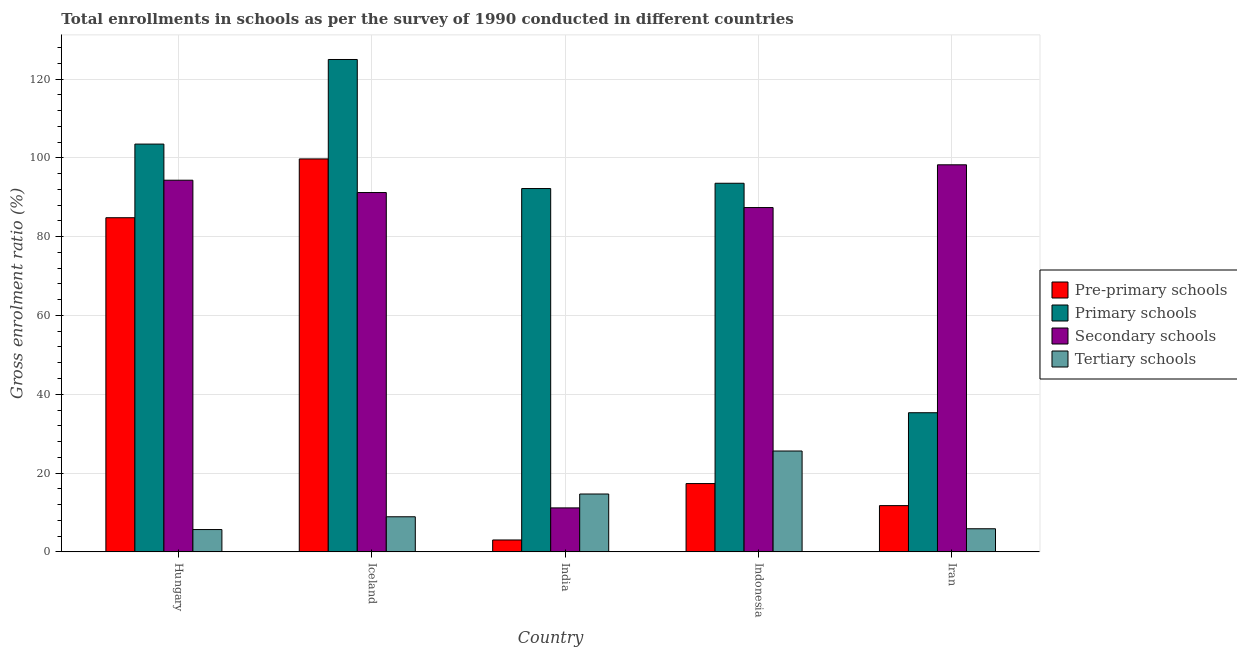How many bars are there on the 1st tick from the left?
Your answer should be compact. 4. What is the label of the 5th group of bars from the left?
Your response must be concise. Iran. In how many cases, is the number of bars for a given country not equal to the number of legend labels?
Your answer should be compact. 0. What is the gross enrolment ratio in pre-primary schools in Iran?
Provide a succinct answer. 11.74. Across all countries, what is the maximum gross enrolment ratio in tertiary schools?
Provide a short and direct response. 25.6. Across all countries, what is the minimum gross enrolment ratio in tertiary schools?
Offer a very short reply. 5.66. In which country was the gross enrolment ratio in primary schools maximum?
Your answer should be very brief. Iceland. In which country was the gross enrolment ratio in secondary schools minimum?
Your answer should be very brief. India. What is the total gross enrolment ratio in secondary schools in the graph?
Your answer should be compact. 382.27. What is the difference between the gross enrolment ratio in secondary schools in India and that in Iran?
Offer a very short reply. -87.06. What is the difference between the gross enrolment ratio in pre-primary schools in Indonesia and the gross enrolment ratio in tertiary schools in Iceland?
Give a very brief answer. 8.42. What is the average gross enrolment ratio in tertiary schools per country?
Your answer should be very brief. 12.14. What is the difference between the gross enrolment ratio in secondary schools and gross enrolment ratio in primary schools in Hungary?
Provide a short and direct response. -9.16. In how many countries, is the gross enrolment ratio in primary schools greater than 72 %?
Make the answer very short. 4. What is the ratio of the gross enrolment ratio in pre-primary schools in India to that in Indonesia?
Provide a succinct answer. 0.17. Is the difference between the gross enrolment ratio in tertiary schools in Iceland and Iran greater than the difference between the gross enrolment ratio in primary schools in Iceland and Iran?
Your response must be concise. No. What is the difference between the highest and the second highest gross enrolment ratio in secondary schools?
Make the answer very short. 3.91. What is the difference between the highest and the lowest gross enrolment ratio in secondary schools?
Offer a very short reply. 87.06. In how many countries, is the gross enrolment ratio in secondary schools greater than the average gross enrolment ratio in secondary schools taken over all countries?
Ensure brevity in your answer.  4. What does the 2nd bar from the left in Indonesia represents?
Provide a succinct answer. Primary schools. What does the 2nd bar from the right in Indonesia represents?
Your answer should be very brief. Secondary schools. Is it the case that in every country, the sum of the gross enrolment ratio in pre-primary schools and gross enrolment ratio in primary schools is greater than the gross enrolment ratio in secondary schools?
Your answer should be compact. No. Are all the bars in the graph horizontal?
Ensure brevity in your answer.  No. What is the difference between two consecutive major ticks on the Y-axis?
Offer a terse response. 20. Are the values on the major ticks of Y-axis written in scientific E-notation?
Your answer should be compact. No. Does the graph contain any zero values?
Provide a short and direct response. No. Does the graph contain grids?
Keep it short and to the point. Yes. How are the legend labels stacked?
Provide a short and direct response. Vertical. What is the title of the graph?
Give a very brief answer. Total enrollments in schools as per the survey of 1990 conducted in different countries. Does "Sweden" appear as one of the legend labels in the graph?
Provide a succinct answer. No. What is the label or title of the Y-axis?
Ensure brevity in your answer.  Gross enrolment ratio (%). What is the Gross enrolment ratio (%) of Pre-primary schools in Hungary?
Offer a very short reply. 84.8. What is the Gross enrolment ratio (%) in Primary schools in Hungary?
Your answer should be compact. 103.48. What is the Gross enrolment ratio (%) of Secondary schools in Hungary?
Give a very brief answer. 94.32. What is the Gross enrolment ratio (%) of Tertiary schools in Hungary?
Your answer should be very brief. 5.66. What is the Gross enrolment ratio (%) in Pre-primary schools in Iceland?
Provide a succinct answer. 99.72. What is the Gross enrolment ratio (%) of Primary schools in Iceland?
Ensure brevity in your answer.  124.95. What is the Gross enrolment ratio (%) of Secondary schools in Iceland?
Your answer should be very brief. 91.19. What is the Gross enrolment ratio (%) in Tertiary schools in Iceland?
Your response must be concise. 8.91. What is the Gross enrolment ratio (%) in Pre-primary schools in India?
Provide a short and direct response. 3.02. What is the Gross enrolment ratio (%) in Primary schools in India?
Provide a short and direct response. 92.2. What is the Gross enrolment ratio (%) in Secondary schools in India?
Your response must be concise. 11.16. What is the Gross enrolment ratio (%) in Tertiary schools in India?
Provide a short and direct response. 14.69. What is the Gross enrolment ratio (%) of Pre-primary schools in Indonesia?
Make the answer very short. 17.33. What is the Gross enrolment ratio (%) of Primary schools in Indonesia?
Make the answer very short. 93.54. What is the Gross enrolment ratio (%) in Secondary schools in Indonesia?
Keep it short and to the point. 87.38. What is the Gross enrolment ratio (%) in Tertiary schools in Indonesia?
Give a very brief answer. 25.6. What is the Gross enrolment ratio (%) of Pre-primary schools in Iran?
Give a very brief answer. 11.74. What is the Gross enrolment ratio (%) in Primary schools in Iran?
Your answer should be very brief. 35.31. What is the Gross enrolment ratio (%) of Secondary schools in Iran?
Make the answer very short. 98.23. What is the Gross enrolment ratio (%) of Tertiary schools in Iran?
Provide a succinct answer. 5.87. Across all countries, what is the maximum Gross enrolment ratio (%) of Pre-primary schools?
Your response must be concise. 99.72. Across all countries, what is the maximum Gross enrolment ratio (%) in Primary schools?
Provide a short and direct response. 124.95. Across all countries, what is the maximum Gross enrolment ratio (%) of Secondary schools?
Offer a terse response. 98.23. Across all countries, what is the maximum Gross enrolment ratio (%) in Tertiary schools?
Provide a succinct answer. 25.6. Across all countries, what is the minimum Gross enrolment ratio (%) of Pre-primary schools?
Make the answer very short. 3.02. Across all countries, what is the minimum Gross enrolment ratio (%) in Primary schools?
Provide a short and direct response. 35.31. Across all countries, what is the minimum Gross enrolment ratio (%) of Secondary schools?
Your answer should be very brief. 11.16. Across all countries, what is the minimum Gross enrolment ratio (%) in Tertiary schools?
Offer a very short reply. 5.66. What is the total Gross enrolment ratio (%) in Pre-primary schools in the graph?
Your answer should be very brief. 216.6. What is the total Gross enrolment ratio (%) of Primary schools in the graph?
Your response must be concise. 449.49. What is the total Gross enrolment ratio (%) of Secondary schools in the graph?
Offer a very short reply. 382.27. What is the total Gross enrolment ratio (%) of Tertiary schools in the graph?
Keep it short and to the point. 60.72. What is the difference between the Gross enrolment ratio (%) in Pre-primary schools in Hungary and that in Iceland?
Provide a short and direct response. -14.92. What is the difference between the Gross enrolment ratio (%) in Primary schools in Hungary and that in Iceland?
Give a very brief answer. -21.47. What is the difference between the Gross enrolment ratio (%) of Secondary schools in Hungary and that in Iceland?
Offer a very short reply. 3.13. What is the difference between the Gross enrolment ratio (%) in Tertiary schools in Hungary and that in Iceland?
Your answer should be compact. -3.24. What is the difference between the Gross enrolment ratio (%) in Pre-primary schools in Hungary and that in India?
Offer a terse response. 81.78. What is the difference between the Gross enrolment ratio (%) in Primary schools in Hungary and that in India?
Your answer should be compact. 11.28. What is the difference between the Gross enrolment ratio (%) of Secondary schools in Hungary and that in India?
Offer a very short reply. 83.16. What is the difference between the Gross enrolment ratio (%) of Tertiary schools in Hungary and that in India?
Keep it short and to the point. -9.02. What is the difference between the Gross enrolment ratio (%) in Pre-primary schools in Hungary and that in Indonesia?
Keep it short and to the point. 67.46. What is the difference between the Gross enrolment ratio (%) of Primary schools in Hungary and that in Indonesia?
Make the answer very short. 9.94. What is the difference between the Gross enrolment ratio (%) of Secondary schools in Hungary and that in Indonesia?
Keep it short and to the point. 6.94. What is the difference between the Gross enrolment ratio (%) in Tertiary schools in Hungary and that in Indonesia?
Provide a short and direct response. -19.93. What is the difference between the Gross enrolment ratio (%) of Pre-primary schools in Hungary and that in Iran?
Offer a terse response. 73.06. What is the difference between the Gross enrolment ratio (%) in Primary schools in Hungary and that in Iran?
Your answer should be compact. 68.17. What is the difference between the Gross enrolment ratio (%) in Secondary schools in Hungary and that in Iran?
Offer a very short reply. -3.91. What is the difference between the Gross enrolment ratio (%) of Tertiary schools in Hungary and that in Iran?
Keep it short and to the point. -0.2. What is the difference between the Gross enrolment ratio (%) of Pre-primary schools in Iceland and that in India?
Give a very brief answer. 96.7. What is the difference between the Gross enrolment ratio (%) of Primary schools in Iceland and that in India?
Ensure brevity in your answer.  32.75. What is the difference between the Gross enrolment ratio (%) of Secondary schools in Iceland and that in India?
Make the answer very short. 80.03. What is the difference between the Gross enrolment ratio (%) in Tertiary schools in Iceland and that in India?
Offer a very short reply. -5.78. What is the difference between the Gross enrolment ratio (%) in Pre-primary schools in Iceland and that in Indonesia?
Keep it short and to the point. 82.38. What is the difference between the Gross enrolment ratio (%) of Primary schools in Iceland and that in Indonesia?
Provide a succinct answer. 31.41. What is the difference between the Gross enrolment ratio (%) in Secondary schools in Iceland and that in Indonesia?
Your answer should be very brief. 3.81. What is the difference between the Gross enrolment ratio (%) in Tertiary schools in Iceland and that in Indonesia?
Offer a very short reply. -16.69. What is the difference between the Gross enrolment ratio (%) of Pre-primary schools in Iceland and that in Iran?
Ensure brevity in your answer.  87.98. What is the difference between the Gross enrolment ratio (%) of Primary schools in Iceland and that in Iran?
Your answer should be compact. 89.64. What is the difference between the Gross enrolment ratio (%) of Secondary schools in Iceland and that in Iran?
Your answer should be compact. -7.04. What is the difference between the Gross enrolment ratio (%) in Tertiary schools in Iceland and that in Iran?
Offer a terse response. 3.04. What is the difference between the Gross enrolment ratio (%) in Pre-primary schools in India and that in Indonesia?
Your answer should be compact. -14.32. What is the difference between the Gross enrolment ratio (%) of Primary schools in India and that in Indonesia?
Provide a succinct answer. -1.34. What is the difference between the Gross enrolment ratio (%) of Secondary schools in India and that in Indonesia?
Your answer should be very brief. -76.22. What is the difference between the Gross enrolment ratio (%) of Tertiary schools in India and that in Indonesia?
Provide a succinct answer. -10.91. What is the difference between the Gross enrolment ratio (%) of Pre-primary schools in India and that in Iran?
Offer a very short reply. -8.72. What is the difference between the Gross enrolment ratio (%) of Primary schools in India and that in Iran?
Your response must be concise. 56.89. What is the difference between the Gross enrolment ratio (%) in Secondary schools in India and that in Iran?
Provide a succinct answer. -87.06. What is the difference between the Gross enrolment ratio (%) in Tertiary schools in India and that in Iran?
Offer a very short reply. 8.82. What is the difference between the Gross enrolment ratio (%) in Pre-primary schools in Indonesia and that in Iran?
Provide a short and direct response. 5.6. What is the difference between the Gross enrolment ratio (%) of Primary schools in Indonesia and that in Iran?
Provide a succinct answer. 58.23. What is the difference between the Gross enrolment ratio (%) of Secondary schools in Indonesia and that in Iran?
Ensure brevity in your answer.  -10.85. What is the difference between the Gross enrolment ratio (%) in Tertiary schools in Indonesia and that in Iran?
Your response must be concise. 19.73. What is the difference between the Gross enrolment ratio (%) in Pre-primary schools in Hungary and the Gross enrolment ratio (%) in Primary schools in Iceland?
Your answer should be compact. -40.15. What is the difference between the Gross enrolment ratio (%) of Pre-primary schools in Hungary and the Gross enrolment ratio (%) of Secondary schools in Iceland?
Make the answer very short. -6.39. What is the difference between the Gross enrolment ratio (%) in Pre-primary schools in Hungary and the Gross enrolment ratio (%) in Tertiary schools in Iceland?
Make the answer very short. 75.89. What is the difference between the Gross enrolment ratio (%) of Primary schools in Hungary and the Gross enrolment ratio (%) of Secondary schools in Iceland?
Make the answer very short. 12.29. What is the difference between the Gross enrolment ratio (%) of Primary schools in Hungary and the Gross enrolment ratio (%) of Tertiary schools in Iceland?
Offer a terse response. 94.57. What is the difference between the Gross enrolment ratio (%) of Secondary schools in Hungary and the Gross enrolment ratio (%) of Tertiary schools in Iceland?
Your answer should be compact. 85.41. What is the difference between the Gross enrolment ratio (%) in Pre-primary schools in Hungary and the Gross enrolment ratio (%) in Primary schools in India?
Offer a very short reply. -7.4. What is the difference between the Gross enrolment ratio (%) of Pre-primary schools in Hungary and the Gross enrolment ratio (%) of Secondary schools in India?
Provide a short and direct response. 73.64. What is the difference between the Gross enrolment ratio (%) of Pre-primary schools in Hungary and the Gross enrolment ratio (%) of Tertiary schools in India?
Make the answer very short. 70.11. What is the difference between the Gross enrolment ratio (%) of Primary schools in Hungary and the Gross enrolment ratio (%) of Secondary schools in India?
Your response must be concise. 92.32. What is the difference between the Gross enrolment ratio (%) in Primary schools in Hungary and the Gross enrolment ratio (%) in Tertiary schools in India?
Your answer should be very brief. 88.8. What is the difference between the Gross enrolment ratio (%) of Secondary schools in Hungary and the Gross enrolment ratio (%) of Tertiary schools in India?
Make the answer very short. 79.63. What is the difference between the Gross enrolment ratio (%) in Pre-primary schools in Hungary and the Gross enrolment ratio (%) in Primary schools in Indonesia?
Provide a short and direct response. -8.74. What is the difference between the Gross enrolment ratio (%) of Pre-primary schools in Hungary and the Gross enrolment ratio (%) of Secondary schools in Indonesia?
Make the answer very short. -2.58. What is the difference between the Gross enrolment ratio (%) of Pre-primary schools in Hungary and the Gross enrolment ratio (%) of Tertiary schools in Indonesia?
Your response must be concise. 59.2. What is the difference between the Gross enrolment ratio (%) in Primary schools in Hungary and the Gross enrolment ratio (%) in Secondary schools in Indonesia?
Make the answer very short. 16.11. What is the difference between the Gross enrolment ratio (%) in Primary schools in Hungary and the Gross enrolment ratio (%) in Tertiary schools in Indonesia?
Your answer should be very brief. 77.89. What is the difference between the Gross enrolment ratio (%) of Secondary schools in Hungary and the Gross enrolment ratio (%) of Tertiary schools in Indonesia?
Make the answer very short. 68.72. What is the difference between the Gross enrolment ratio (%) of Pre-primary schools in Hungary and the Gross enrolment ratio (%) of Primary schools in Iran?
Keep it short and to the point. 49.49. What is the difference between the Gross enrolment ratio (%) in Pre-primary schools in Hungary and the Gross enrolment ratio (%) in Secondary schools in Iran?
Ensure brevity in your answer.  -13.43. What is the difference between the Gross enrolment ratio (%) in Pre-primary schools in Hungary and the Gross enrolment ratio (%) in Tertiary schools in Iran?
Offer a terse response. 78.93. What is the difference between the Gross enrolment ratio (%) in Primary schools in Hungary and the Gross enrolment ratio (%) in Secondary schools in Iran?
Offer a terse response. 5.26. What is the difference between the Gross enrolment ratio (%) of Primary schools in Hungary and the Gross enrolment ratio (%) of Tertiary schools in Iran?
Give a very brief answer. 97.62. What is the difference between the Gross enrolment ratio (%) of Secondary schools in Hungary and the Gross enrolment ratio (%) of Tertiary schools in Iran?
Your response must be concise. 88.45. What is the difference between the Gross enrolment ratio (%) of Pre-primary schools in Iceland and the Gross enrolment ratio (%) of Primary schools in India?
Ensure brevity in your answer.  7.52. What is the difference between the Gross enrolment ratio (%) of Pre-primary schools in Iceland and the Gross enrolment ratio (%) of Secondary schools in India?
Provide a short and direct response. 88.56. What is the difference between the Gross enrolment ratio (%) in Pre-primary schools in Iceland and the Gross enrolment ratio (%) in Tertiary schools in India?
Make the answer very short. 85.03. What is the difference between the Gross enrolment ratio (%) in Primary schools in Iceland and the Gross enrolment ratio (%) in Secondary schools in India?
Offer a very short reply. 113.79. What is the difference between the Gross enrolment ratio (%) in Primary schools in Iceland and the Gross enrolment ratio (%) in Tertiary schools in India?
Your answer should be very brief. 110.26. What is the difference between the Gross enrolment ratio (%) in Secondary schools in Iceland and the Gross enrolment ratio (%) in Tertiary schools in India?
Your answer should be very brief. 76.5. What is the difference between the Gross enrolment ratio (%) in Pre-primary schools in Iceland and the Gross enrolment ratio (%) in Primary schools in Indonesia?
Keep it short and to the point. 6.17. What is the difference between the Gross enrolment ratio (%) of Pre-primary schools in Iceland and the Gross enrolment ratio (%) of Secondary schools in Indonesia?
Offer a very short reply. 12.34. What is the difference between the Gross enrolment ratio (%) in Pre-primary schools in Iceland and the Gross enrolment ratio (%) in Tertiary schools in Indonesia?
Offer a terse response. 74.12. What is the difference between the Gross enrolment ratio (%) of Primary schools in Iceland and the Gross enrolment ratio (%) of Secondary schools in Indonesia?
Provide a succinct answer. 37.57. What is the difference between the Gross enrolment ratio (%) of Primary schools in Iceland and the Gross enrolment ratio (%) of Tertiary schools in Indonesia?
Make the answer very short. 99.35. What is the difference between the Gross enrolment ratio (%) in Secondary schools in Iceland and the Gross enrolment ratio (%) in Tertiary schools in Indonesia?
Your answer should be compact. 65.59. What is the difference between the Gross enrolment ratio (%) in Pre-primary schools in Iceland and the Gross enrolment ratio (%) in Primary schools in Iran?
Your answer should be very brief. 64.41. What is the difference between the Gross enrolment ratio (%) in Pre-primary schools in Iceland and the Gross enrolment ratio (%) in Secondary schools in Iran?
Offer a very short reply. 1.49. What is the difference between the Gross enrolment ratio (%) in Pre-primary schools in Iceland and the Gross enrolment ratio (%) in Tertiary schools in Iran?
Offer a very short reply. 93.85. What is the difference between the Gross enrolment ratio (%) of Primary schools in Iceland and the Gross enrolment ratio (%) of Secondary schools in Iran?
Your response must be concise. 26.73. What is the difference between the Gross enrolment ratio (%) of Primary schools in Iceland and the Gross enrolment ratio (%) of Tertiary schools in Iran?
Your answer should be very brief. 119.08. What is the difference between the Gross enrolment ratio (%) in Secondary schools in Iceland and the Gross enrolment ratio (%) in Tertiary schools in Iran?
Your response must be concise. 85.32. What is the difference between the Gross enrolment ratio (%) in Pre-primary schools in India and the Gross enrolment ratio (%) in Primary schools in Indonesia?
Make the answer very short. -90.52. What is the difference between the Gross enrolment ratio (%) of Pre-primary schools in India and the Gross enrolment ratio (%) of Secondary schools in Indonesia?
Offer a very short reply. -84.36. What is the difference between the Gross enrolment ratio (%) in Pre-primary schools in India and the Gross enrolment ratio (%) in Tertiary schools in Indonesia?
Your answer should be very brief. -22.58. What is the difference between the Gross enrolment ratio (%) of Primary schools in India and the Gross enrolment ratio (%) of Secondary schools in Indonesia?
Your response must be concise. 4.82. What is the difference between the Gross enrolment ratio (%) of Primary schools in India and the Gross enrolment ratio (%) of Tertiary schools in Indonesia?
Your answer should be compact. 66.6. What is the difference between the Gross enrolment ratio (%) of Secondary schools in India and the Gross enrolment ratio (%) of Tertiary schools in Indonesia?
Offer a terse response. -14.44. What is the difference between the Gross enrolment ratio (%) of Pre-primary schools in India and the Gross enrolment ratio (%) of Primary schools in Iran?
Your response must be concise. -32.29. What is the difference between the Gross enrolment ratio (%) of Pre-primary schools in India and the Gross enrolment ratio (%) of Secondary schools in Iran?
Your answer should be compact. -95.21. What is the difference between the Gross enrolment ratio (%) in Pre-primary schools in India and the Gross enrolment ratio (%) in Tertiary schools in Iran?
Provide a succinct answer. -2.85. What is the difference between the Gross enrolment ratio (%) of Primary schools in India and the Gross enrolment ratio (%) of Secondary schools in Iran?
Provide a short and direct response. -6.02. What is the difference between the Gross enrolment ratio (%) in Primary schools in India and the Gross enrolment ratio (%) in Tertiary schools in Iran?
Provide a short and direct response. 86.34. What is the difference between the Gross enrolment ratio (%) of Secondary schools in India and the Gross enrolment ratio (%) of Tertiary schools in Iran?
Offer a very short reply. 5.3. What is the difference between the Gross enrolment ratio (%) of Pre-primary schools in Indonesia and the Gross enrolment ratio (%) of Primary schools in Iran?
Offer a terse response. -17.98. What is the difference between the Gross enrolment ratio (%) of Pre-primary schools in Indonesia and the Gross enrolment ratio (%) of Secondary schools in Iran?
Your answer should be compact. -80.89. What is the difference between the Gross enrolment ratio (%) of Pre-primary schools in Indonesia and the Gross enrolment ratio (%) of Tertiary schools in Iran?
Offer a very short reply. 11.47. What is the difference between the Gross enrolment ratio (%) in Primary schools in Indonesia and the Gross enrolment ratio (%) in Secondary schools in Iran?
Offer a very short reply. -4.68. What is the difference between the Gross enrolment ratio (%) of Primary schools in Indonesia and the Gross enrolment ratio (%) of Tertiary schools in Iran?
Provide a short and direct response. 87.68. What is the difference between the Gross enrolment ratio (%) of Secondary schools in Indonesia and the Gross enrolment ratio (%) of Tertiary schools in Iran?
Provide a short and direct response. 81.51. What is the average Gross enrolment ratio (%) in Pre-primary schools per country?
Your answer should be very brief. 43.32. What is the average Gross enrolment ratio (%) of Primary schools per country?
Give a very brief answer. 89.9. What is the average Gross enrolment ratio (%) of Secondary schools per country?
Make the answer very short. 76.45. What is the average Gross enrolment ratio (%) in Tertiary schools per country?
Give a very brief answer. 12.14. What is the difference between the Gross enrolment ratio (%) of Pre-primary schools and Gross enrolment ratio (%) of Primary schools in Hungary?
Your answer should be compact. -18.68. What is the difference between the Gross enrolment ratio (%) of Pre-primary schools and Gross enrolment ratio (%) of Secondary schools in Hungary?
Keep it short and to the point. -9.52. What is the difference between the Gross enrolment ratio (%) in Pre-primary schools and Gross enrolment ratio (%) in Tertiary schools in Hungary?
Provide a short and direct response. 79.13. What is the difference between the Gross enrolment ratio (%) of Primary schools and Gross enrolment ratio (%) of Secondary schools in Hungary?
Your answer should be very brief. 9.16. What is the difference between the Gross enrolment ratio (%) in Primary schools and Gross enrolment ratio (%) in Tertiary schools in Hungary?
Ensure brevity in your answer.  97.82. What is the difference between the Gross enrolment ratio (%) in Secondary schools and Gross enrolment ratio (%) in Tertiary schools in Hungary?
Keep it short and to the point. 88.65. What is the difference between the Gross enrolment ratio (%) of Pre-primary schools and Gross enrolment ratio (%) of Primary schools in Iceland?
Ensure brevity in your answer.  -25.23. What is the difference between the Gross enrolment ratio (%) of Pre-primary schools and Gross enrolment ratio (%) of Secondary schools in Iceland?
Provide a short and direct response. 8.53. What is the difference between the Gross enrolment ratio (%) in Pre-primary schools and Gross enrolment ratio (%) in Tertiary schools in Iceland?
Provide a short and direct response. 90.81. What is the difference between the Gross enrolment ratio (%) of Primary schools and Gross enrolment ratio (%) of Secondary schools in Iceland?
Keep it short and to the point. 33.76. What is the difference between the Gross enrolment ratio (%) of Primary schools and Gross enrolment ratio (%) of Tertiary schools in Iceland?
Your answer should be very brief. 116.04. What is the difference between the Gross enrolment ratio (%) of Secondary schools and Gross enrolment ratio (%) of Tertiary schools in Iceland?
Provide a succinct answer. 82.28. What is the difference between the Gross enrolment ratio (%) of Pre-primary schools and Gross enrolment ratio (%) of Primary schools in India?
Ensure brevity in your answer.  -89.18. What is the difference between the Gross enrolment ratio (%) of Pre-primary schools and Gross enrolment ratio (%) of Secondary schools in India?
Provide a succinct answer. -8.14. What is the difference between the Gross enrolment ratio (%) of Pre-primary schools and Gross enrolment ratio (%) of Tertiary schools in India?
Make the answer very short. -11.67. What is the difference between the Gross enrolment ratio (%) in Primary schools and Gross enrolment ratio (%) in Secondary schools in India?
Provide a short and direct response. 81.04. What is the difference between the Gross enrolment ratio (%) in Primary schools and Gross enrolment ratio (%) in Tertiary schools in India?
Ensure brevity in your answer.  77.52. What is the difference between the Gross enrolment ratio (%) in Secondary schools and Gross enrolment ratio (%) in Tertiary schools in India?
Make the answer very short. -3.52. What is the difference between the Gross enrolment ratio (%) of Pre-primary schools and Gross enrolment ratio (%) of Primary schools in Indonesia?
Provide a succinct answer. -76.21. What is the difference between the Gross enrolment ratio (%) in Pre-primary schools and Gross enrolment ratio (%) in Secondary schools in Indonesia?
Provide a short and direct response. -70.04. What is the difference between the Gross enrolment ratio (%) of Pre-primary schools and Gross enrolment ratio (%) of Tertiary schools in Indonesia?
Your answer should be very brief. -8.26. What is the difference between the Gross enrolment ratio (%) of Primary schools and Gross enrolment ratio (%) of Secondary schools in Indonesia?
Ensure brevity in your answer.  6.17. What is the difference between the Gross enrolment ratio (%) of Primary schools and Gross enrolment ratio (%) of Tertiary schools in Indonesia?
Give a very brief answer. 67.95. What is the difference between the Gross enrolment ratio (%) in Secondary schools and Gross enrolment ratio (%) in Tertiary schools in Indonesia?
Offer a very short reply. 61.78. What is the difference between the Gross enrolment ratio (%) of Pre-primary schools and Gross enrolment ratio (%) of Primary schools in Iran?
Offer a very short reply. -23.57. What is the difference between the Gross enrolment ratio (%) in Pre-primary schools and Gross enrolment ratio (%) in Secondary schools in Iran?
Make the answer very short. -86.49. What is the difference between the Gross enrolment ratio (%) in Pre-primary schools and Gross enrolment ratio (%) in Tertiary schools in Iran?
Your answer should be very brief. 5.87. What is the difference between the Gross enrolment ratio (%) in Primary schools and Gross enrolment ratio (%) in Secondary schools in Iran?
Make the answer very short. -62.92. What is the difference between the Gross enrolment ratio (%) in Primary schools and Gross enrolment ratio (%) in Tertiary schools in Iran?
Make the answer very short. 29.44. What is the difference between the Gross enrolment ratio (%) in Secondary schools and Gross enrolment ratio (%) in Tertiary schools in Iran?
Your answer should be compact. 92.36. What is the ratio of the Gross enrolment ratio (%) in Pre-primary schools in Hungary to that in Iceland?
Provide a succinct answer. 0.85. What is the ratio of the Gross enrolment ratio (%) in Primary schools in Hungary to that in Iceland?
Offer a terse response. 0.83. What is the ratio of the Gross enrolment ratio (%) of Secondary schools in Hungary to that in Iceland?
Make the answer very short. 1.03. What is the ratio of the Gross enrolment ratio (%) in Tertiary schools in Hungary to that in Iceland?
Offer a very short reply. 0.64. What is the ratio of the Gross enrolment ratio (%) in Pre-primary schools in Hungary to that in India?
Give a very brief answer. 28.09. What is the ratio of the Gross enrolment ratio (%) of Primary schools in Hungary to that in India?
Your answer should be very brief. 1.12. What is the ratio of the Gross enrolment ratio (%) of Secondary schools in Hungary to that in India?
Your answer should be compact. 8.45. What is the ratio of the Gross enrolment ratio (%) of Tertiary schools in Hungary to that in India?
Offer a very short reply. 0.39. What is the ratio of the Gross enrolment ratio (%) in Pre-primary schools in Hungary to that in Indonesia?
Provide a short and direct response. 4.89. What is the ratio of the Gross enrolment ratio (%) in Primary schools in Hungary to that in Indonesia?
Give a very brief answer. 1.11. What is the ratio of the Gross enrolment ratio (%) of Secondary schools in Hungary to that in Indonesia?
Provide a short and direct response. 1.08. What is the ratio of the Gross enrolment ratio (%) in Tertiary schools in Hungary to that in Indonesia?
Ensure brevity in your answer.  0.22. What is the ratio of the Gross enrolment ratio (%) in Pre-primary schools in Hungary to that in Iran?
Make the answer very short. 7.22. What is the ratio of the Gross enrolment ratio (%) in Primary schools in Hungary to that in Iran?
Give a very brief answer. 2.93. What is the ratio of the Gross enrolment ratio (%) of Secondary schools in Hungary to that in Iran?
Keep it short and to the point. 0.96. What is the ratio of the Gross enrolment ratio (%) of Tertiary schools in Hungary to that in Iran?
Your answer should be compact. 0.97. What is the ratio of the Gross enrolment ratio (%) of Pre-primary schools in Iceland to that in India?
Ensure brevity in your answer.  33.04. What is the ratio of the Gross enrolment ratio (%) in Primary schools in Iceland to that in India?
Offer a very short reply. 1.36. What is the ratio of the Gross enrolment ratio (%) in Secondary schools in Iceland to that in India?
Provide a succinct answer. 8.17. What is the ratio of the Gross enrolment ratio (%) of Tertiary schools in Iceland to that in India?
Offer a terse response. 0.61. What is the ratio of the Gross enrolment ratio (%) in Pre-primary schools in Iceland to that in Indonesia?
Offer a terse response. 5.75. What is the ratio of the Gross enrolment ratio (%) of Primary schools in Iceland to that in Indonesia?
Offer a terse response. 1.34. What is the ratio of the Gross enrolment ratio (%) in Secondary schools in Iceland to that in Indonesia?
Give a very brief answer. 1.04. What is the ratio of the Gross enrolment ratio (%) in Tertiary schools in Iceland to that in Indonesia?
Provide a short and direct response. 0.35. What is the ratio of the Gross enrolment ratio (%) in Pre-primary schools in Iceland to that in Iran?
Your response must be concise. 8.5. What is the ratio of the Gross enrolment ratio (%) of Primary schools in Iceland to that in Iran?
Offer a terse response. 3.54. What is the ratio of the Gross enrolment ratio (%) in Secondary schools in Iceland to that in Iran?
Your answer should be compact. 0.93. What is the ratio of the Gross enrolment ratio (%) in Tertiary schools in Iceland to that in Iran?
Give a very brief answer. 1.52. What is the ratio of the Gross enrolment ratio (%) in Pre-primary schools in India to that in Indonesia?
Your answer should be very brief. 0.17. What is the ratio of the Gross enrolment ratio (%) in Primary schools in India to that in Indonesia?
Your answer should be very brief. 0.99. What is the ratio of the Gross enrolment ratio (%) in Secondary schools in India to that in Indonesia?
Offer a very short reply. 0.13. What is the ratio of the Gross enrolment ratio (%) of Tertiary schools in India to that in Indonesia?
Your response must be concise. 0.57. What is the ratio of the Gross enrolment ratio (%) of Pre-primary schools in India to that in Iran?
Provide a succinct answer. 0.26. What is the ratio of the Gross enrolment ratio (%) of Primary schools in India to that in Iran?
Offer a terse response. 2.61. What is the ratio of the Gross enrolment ratio (%) in Secondary schools in India to that in Iran?
Provide a succinct answer. 0.11. What is the ratio of the Gross enrolment ratio (%) in Tertiary schools in India to that in Iran?
Provide a succinct answer. 2.5. What is the ratio of the Gross enrolment ratio (%) of Pre-primary schools in Indonesia to that in Iran?
Offer a terse response. 1.48. What is the ratio of the Gross enrolment ratio (%) in Primary schools in Indonesia to that in Iran?
Provide a short and direct response. 2.65. What is the ratio of the Gross enrolment ratio (%) of Secondary schools in Indonesia to that in Iran?
Your answer should be very brief. 0.89. What is the ratio of the Gross enrolment ratio (%) of Tertiary schools in Indonesia to that in Iran?
Keep it short and to the point. 4.36. What is the difference between the highest and the second highest Gross enrolment ratio (%) of Pre-primary schools?
Ensure brevity in your answer.  14.92. What is the difference between the highest and the second highest Gross enrolment ratio (%) in Primary schools?
Keep it short and to the point. 21.47. What is the difference between the highest and the second highest Gross enrolment ratio (%) in Secondary schools?
Your answer should be compact. 3.91. What is the difference between the highest and the second highest Gross enrolment ratio (%) of Tertiary schools?
Your answer should be very brief. 10.91. What is the difference between the highest and the lowest Gross enrolment ratio (%) of Pre-primary schools?
Your response must be concise. 96.7. What is the difference between the highest and the lowest Gross enrolment ratio (%) of Primary schools?
Ensure brevity in your answer.  89.64. What is the difference between the highest and the lowest Gross enrolment ratio (%) of Secondary schools?
Offer a terse response. 87.06. What is the difference between the highest and the lowest Gross enrolment ratio (%) in Tertiary schools?
Offer a very short reply. 19.93. 